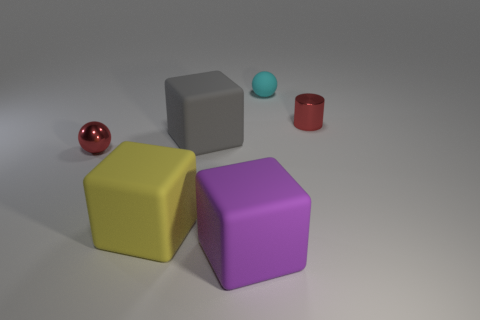Subtract 1 cubes. How many cubes are left? 2 Add 3 small brown matte cylinders. How many objects exist? 9 Subtract all cylinders. How many objects are left? 5 Add 5 yellow matte objects. How many yellow matte objects exist? 6 Subtract 1 purple blocks. How many objects are left? 5 Subtract all tiny spheres. Subtract all cylinders. How many objects are left? 3 Add 6 purple rubber objects. How many purple rubber objects are left? 7 